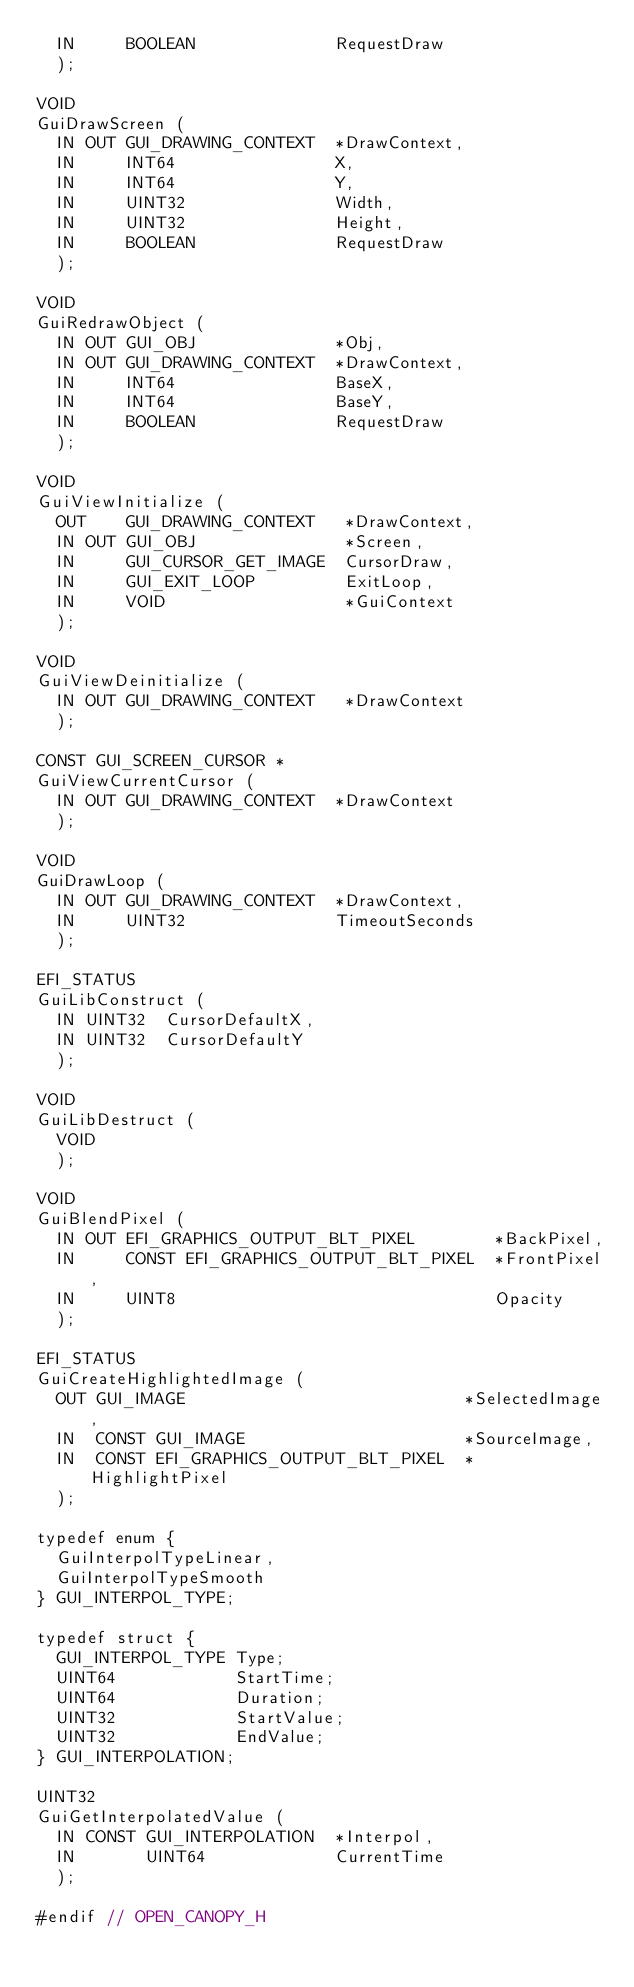<code> <loc_0><loc_0><loc_500><loc_500><_C_>  IN     BOOLEAN              RequestDraw
  );

VOID
GuiDrawScreen (
  IN OUT GUI_DRAWING_CONTEXT  *DrawContext,
  IN     INT64                X,
  IN     INT64                Y,
  IN     UINT32               Width,
  IN     UINT32               Height,
  IN     BOOLEAN              RequestDraw
  );

VOID
GuiRedrawObject (
  IN OUT GUI_OBJ              *Obj,
  IN OUT GUI_DRAWING_CONTEXT  *DrawContext,
  IN     INT64                BaseX,
  IN     INT64                BaseY,
  IN     BOOLEAN              RequestDraw
  );

VOID
GuiViewInitialize (
  OUT    GUI_DRAWING_CONTEXT   *DrawContext,
  IN OUT GUI_OBJ               *Screen,
  IN     GUI_CURSOR_GET_IMAGE  CursorDraw,
  IN     GUI_EXIT_LOOP         ExitLoop,
  IN     VOID                  *GuiContext
  );

VOID
GuiViewDeinitialize (
  IN OUT GUI_DRAWING_CONTEXT   *DrawContext
  );

CONST GUI_SCREEN_CURSOR *
GuiViewCurrentCursor (
  IN OUT GUI_DRAWING_CONTEXT  *DrawContext
  );

VOID
GuiDrawLoop (
  IN OUT GUI_DRAWING_CONTEXT  *DrawContext,
  IN     UINT32               TimeoutSeconds
  );

EFI_STATUS
GuiLibConstruct (
  IN UINT32  CursorDefaultX,
  IN UINT32  CursorDefaultY
  );

VOID
GuiLibDestruct (
  VOID
  );

VOID
GuiBlendPixel (
  IN OUT EFI_GRAPHICS_OUTPUT_BLT_PIXEL        *BackPixel,
  IN     CONST EFI_GRAPHICS_OUTPUT_BLT_PIXEL  *FrontPixel,
  IN     UINT8                                Opacity
  );

EFI_STATUS
GuiCreateHighlightedImage (
  OUT GUI_IMAGE                            *SelectedImage,
  IN  CONST GUI_IMAGE                      *SourceImage,
  IN  CONST EFI_GRAPHICS_OUTPUT_BLT_PIXEL  *HighlightPixel
  );

typedef enum {
  GuiInterpolTypeLinear,
  GuiInterpolTypeSmooth
} GUI_INTERPOL_TYPE;

typedef struct {
  GUI_INTERPOL_TYPE Type;
  UINT64            StartTime;
  UINT64            Duration;
  UINT32            StartValue;
  UINT32            EndValue;
} GUI_INTERPOLATION;

UINT32
GuiGetInterpolatedValue (
  IN CONST GUI_INTERPOLATION  *Interpol,
  IN       UINT64             CurrentTime
  );

#endif // OPEN_CANOPY_H
</code> 